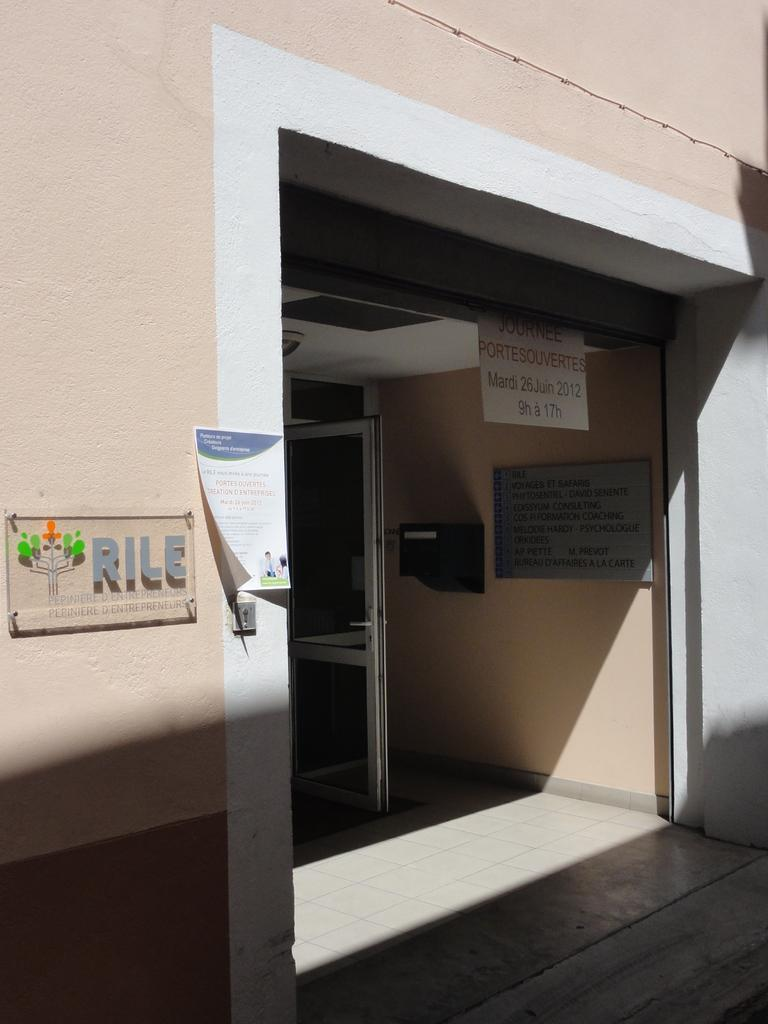What is the main structure in the image? There is a building in the middle of the image. Can you describe the entrance of the building? The entrance of the building has two doors. What can be seen on the left side of the image? There is a board on the wall on the left side of the image. What kind of trouble are the boys causing at the church in the image? There are no boys or church present in the image; it features a building with an entrance and a board on the wall. 